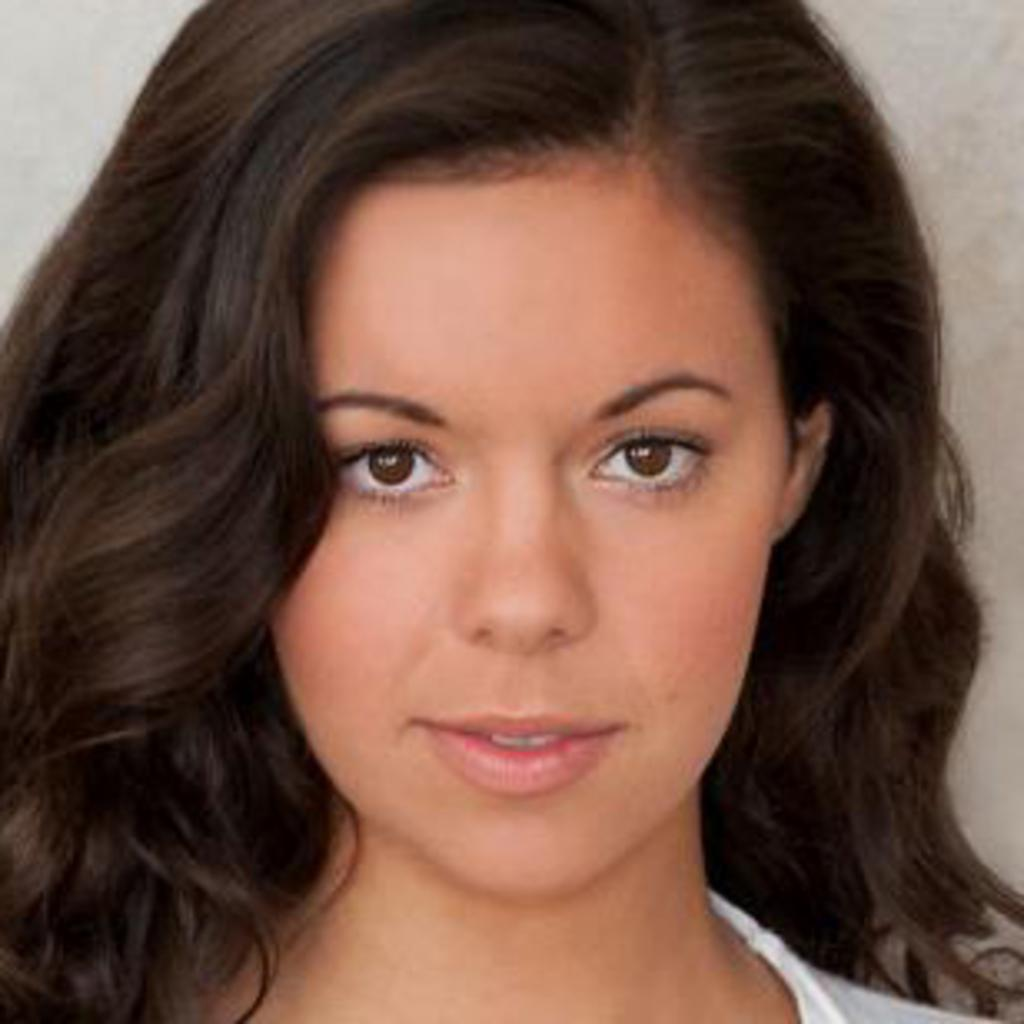Who is the main subject in the image? There is a woman in the image. Where is the woman located in the image? The woman is in the middle of the image. What color is the background of the image? The background of the image is white. What type of plant or flower can be seen in the image? There is no plant or flower present in the image; it features a woman in the middle of a white background. 